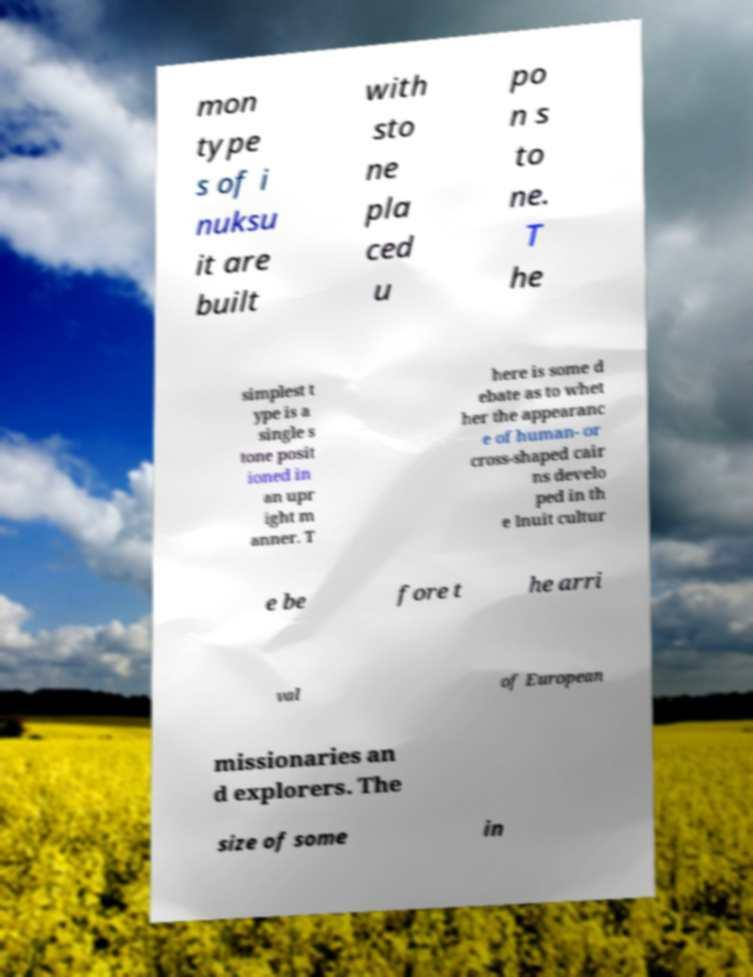What messages or text are displayed in this image? I need them in a readable, typed format. mon type s of i nuksu it are built with sto ne pla ced u po n s to ne. T he simplest t ype is a single s tone posit ioned in an upr ight m anner. T here is some d ebate as to whet her the appearanc e of human- or cross-shaped cair ns develo ped in th e Inuit cultur e be fore t he arri val of European missionaries an d explorers. The size of some in 